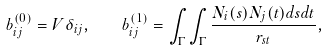<formula> <loc_0><loc_0><loc_500><loc_500>b ^ { ( 0 ) } _ { i j } = V \delta _ { i j } , \quad b ^ { ( 1 ) } _ { i j } = \int _ { \Gamma } \int _ { \Gamma } \frac { N _ { i } ( s ) N _ { j } ( t ) d s d t } { r _ { s t } } ,</formula> 